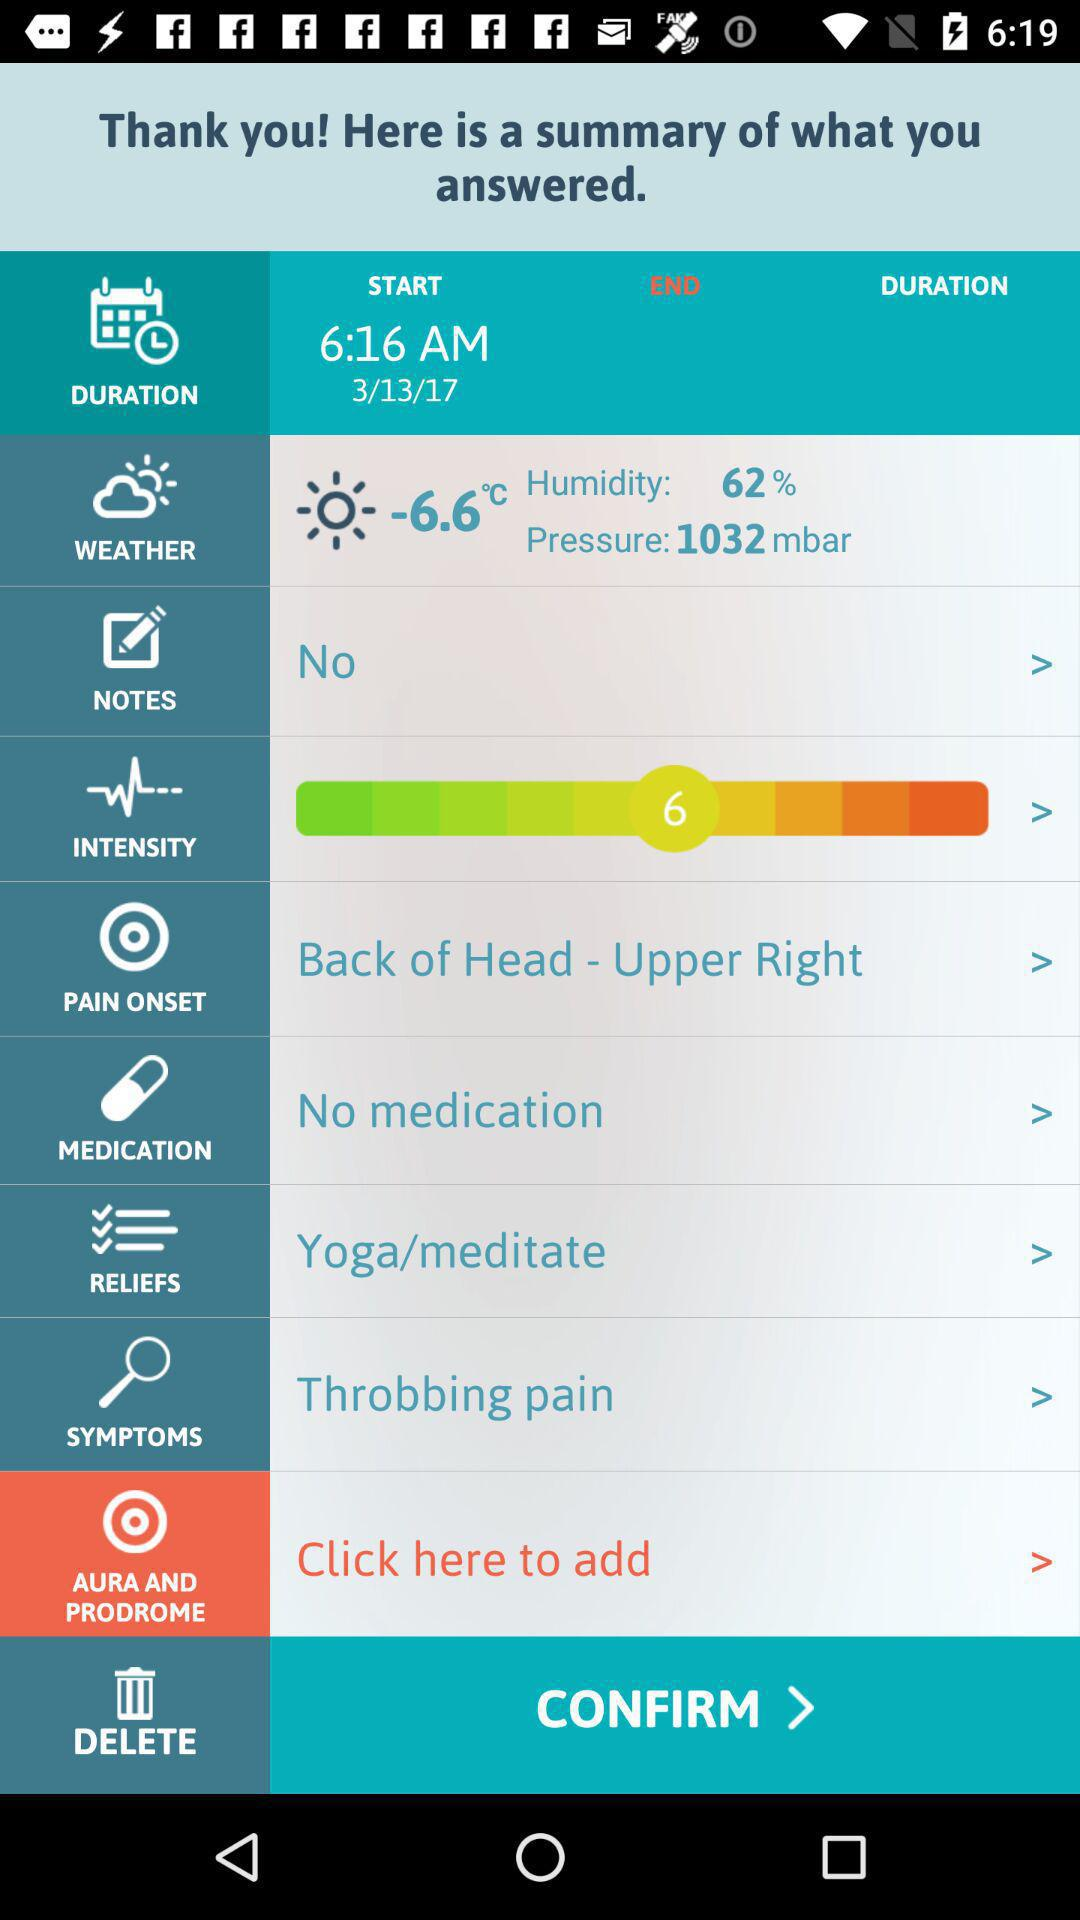Which date is selected to start? The selected date is March 13, 2017. 